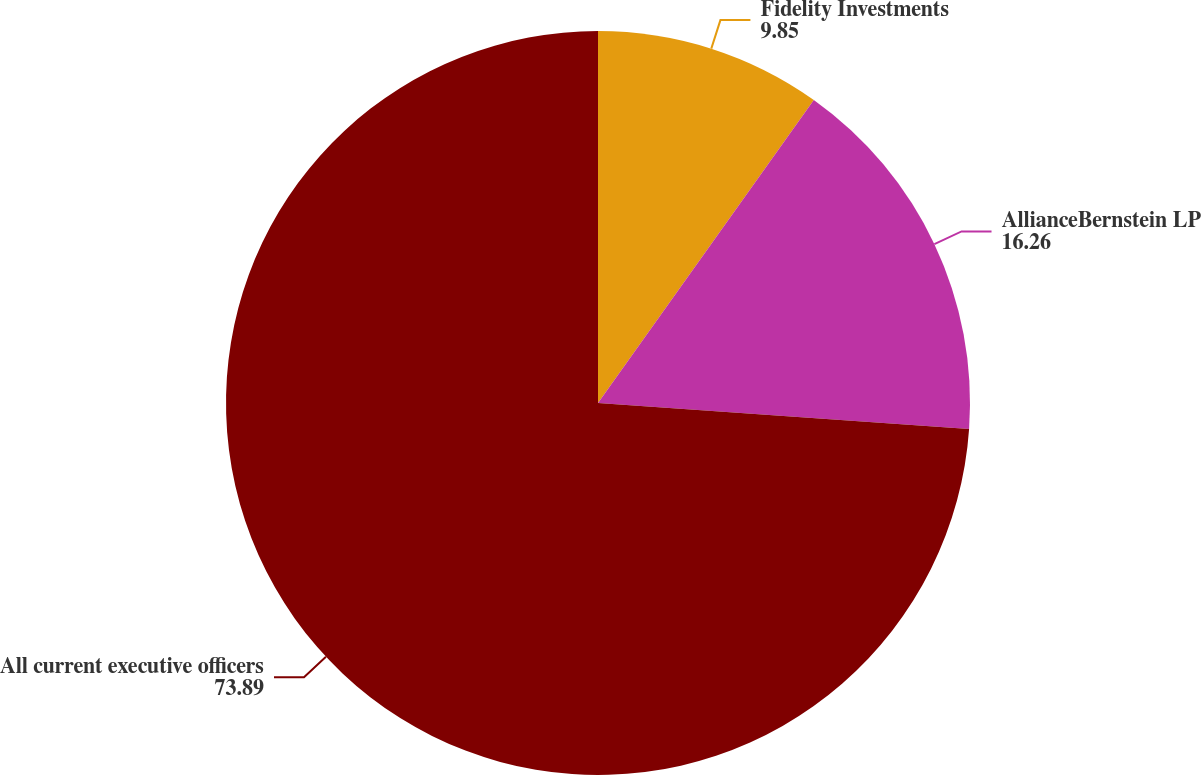<chart> <loc_0><loc_0><loc_500><loc_500><pie_chart><fcel>Fidelity Investments<fcel>AllianceBernstein LP<fcel>All current executive officers<nl><fcel>9.85%<fcel>16.26%<fcel>73.89%<nl></chart> 